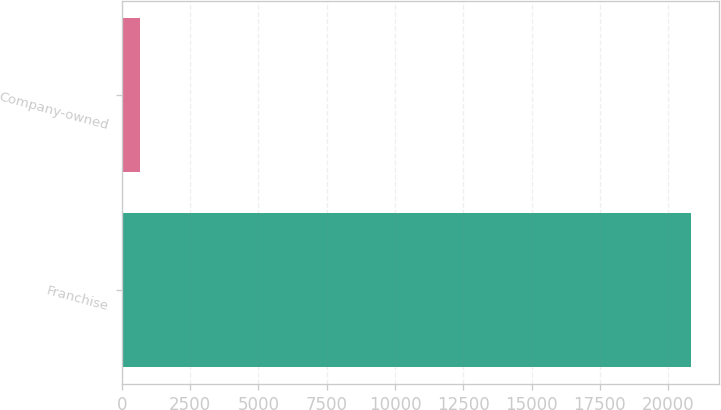Convert chart to OTSL. <chart><loc_0><loc_0><loc_500><loc_500><bar_chart><fcel>Franchise<fcel>Company-owned<nl><fcel>20819<fcel>668<nl></chart> 